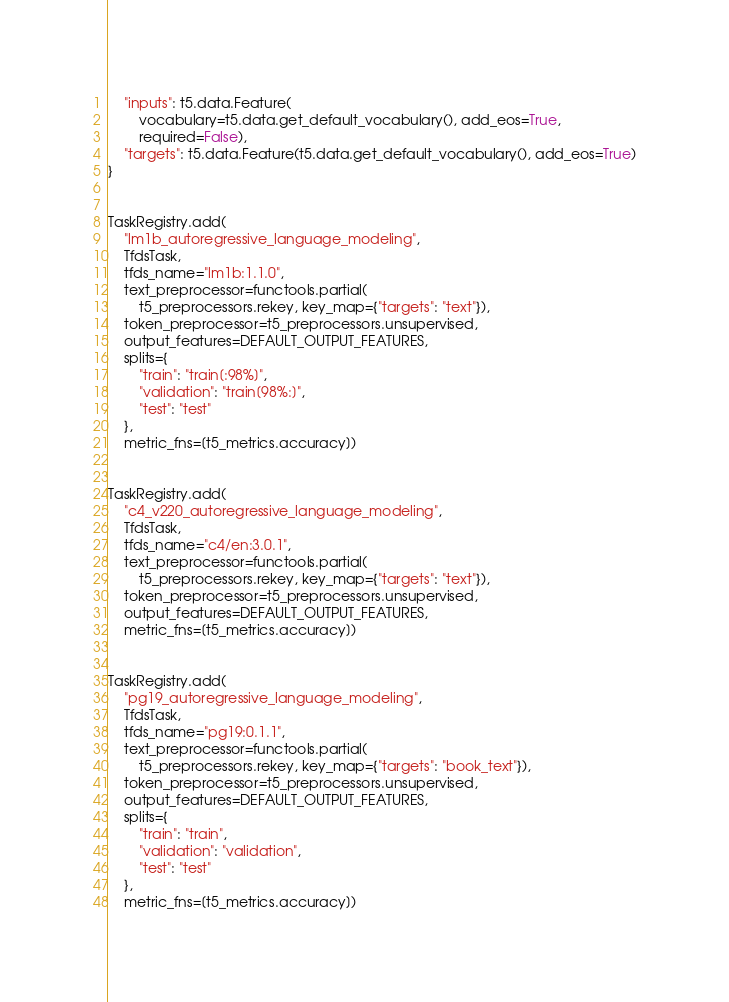Convert code to text. <code><loc_0><loc_0><loc_500><loc_500><_Python_>    "inputs": t5.data.Feature(
        vocabulary=t5.data.get_default_vocabulary(), add_eos=True,
        required=False),
    "targets": t5.data.Feature(t5.data.get_default_vocabulary(), add_eos=True)
}


TaskRegistry.add(
    "lm1b_autoregressive_language_modeling",
    TfdsTask,
    tfds_name="lm1b:1.1.0",
    text_preprocessor=functools.partial(
        t5_preprocessors.rekey, key_map={"targets": "text"}),
    token_preprocessor=t5_preprocessors.unsupervised,
    output_features=DEFAULT_OUTPUT_FEATURES,
    splits={
        "train": "train[:98%]",
        "validation": "train[98%:]",
        "test": "test"
    },
    metric_fns=[t5_metrics.accuracy])


TaskRegistry.add(
    "c4_v220_autoregressive_language_modeling",
    TfdsTask,
    tfds_name="c4/en:3.0.1",
    text_preprocessor=functools.partial(
        t5_preprocessors.rekey, key_map={"targets": "text"}),
    token_preprocessor=t5_preprocessors.unsupervised,
    output_features=DEFAULT_OUTPUT_FEATURES,
    metric_fns=[t5_metrics.accuracy])


TaskRegistry.add(
    "pg19_autoregressive_language_modeling",
    TfdsTask,
    tfds_name="pg19:0.1.1",
    text_preprocessor=functools.partial(
        t5_preprocessors.rekey, key_map={"targets": "book_text"}),
    token_preprocessor=t5_preprocessors.unsupervised,
    output_features=DEFAULT_OUTPUT_FEATURES,
    splits={
        "train": "train",
        "validation": "validation",
        "test": "test"
    },
    metric_fns=[t5_metrics.accuracy])
</code> 